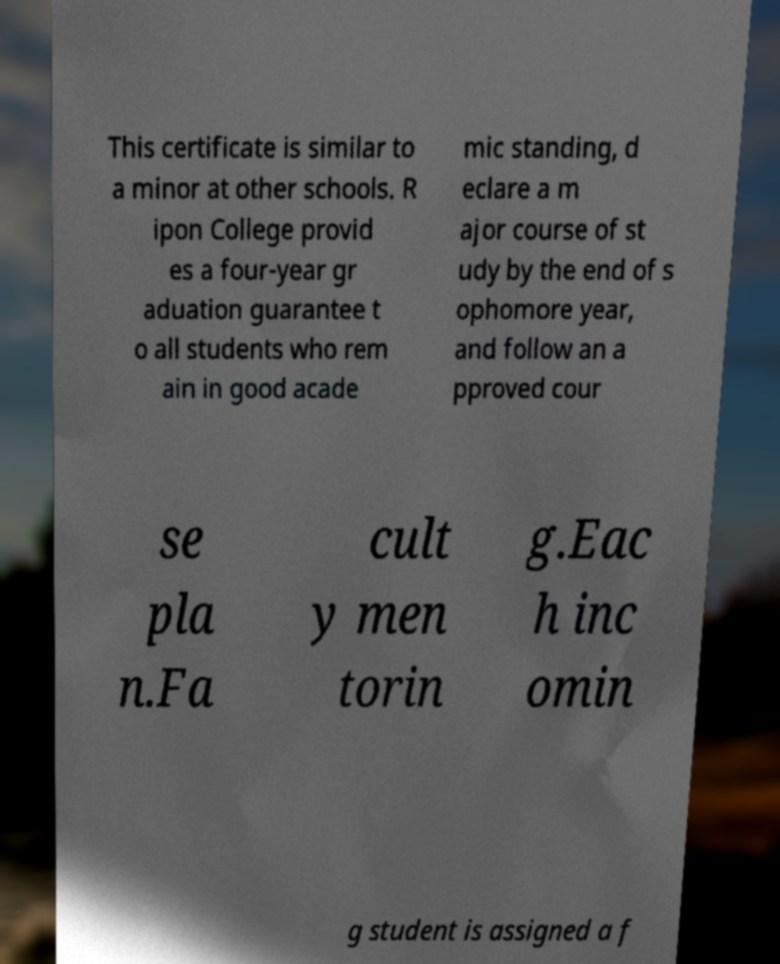For documentation purposes, I need the text within this image transcribed. Could you provide that? This certificate is similar to a minor at other schools. R ipon College provid es a four-year gr aduation guarantee t o all students who rem ain in good acade mic standing, d eclare a m ajor course of st udy by the end of s ophomore year, and follow an a pproved cour se pla n.Fa cult y men torin g.Eac h inc omin g student is assigned a f 